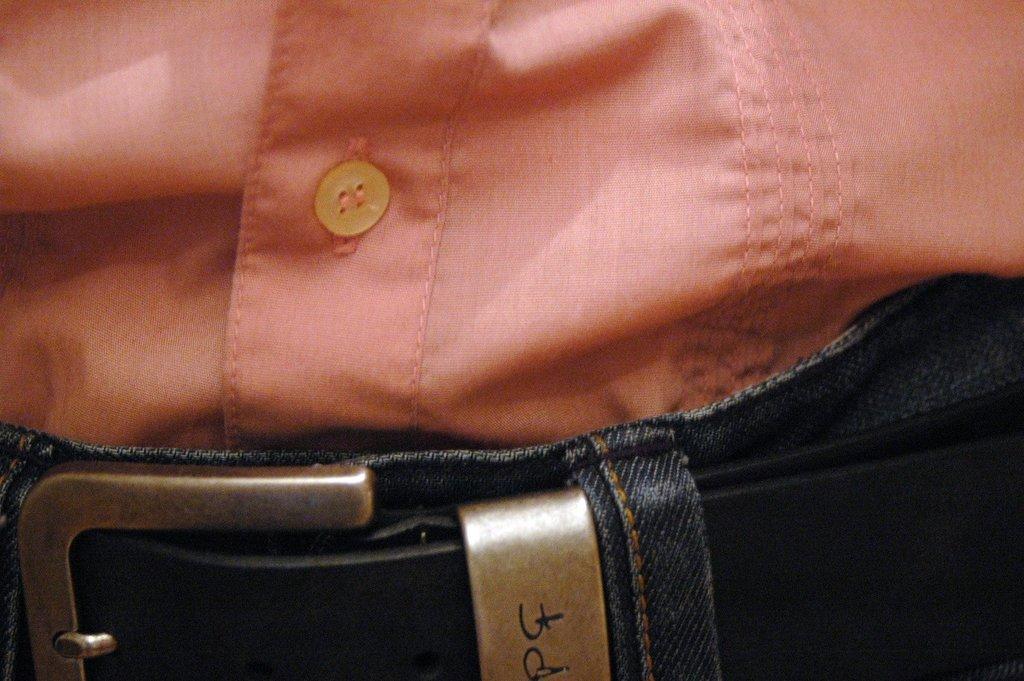In one or two sentences, can you explain what this image depicts? In the picture we can see a part of shirt inside the trouser and to the trouser we can see a belt and the shirt is orange in color with a button. 